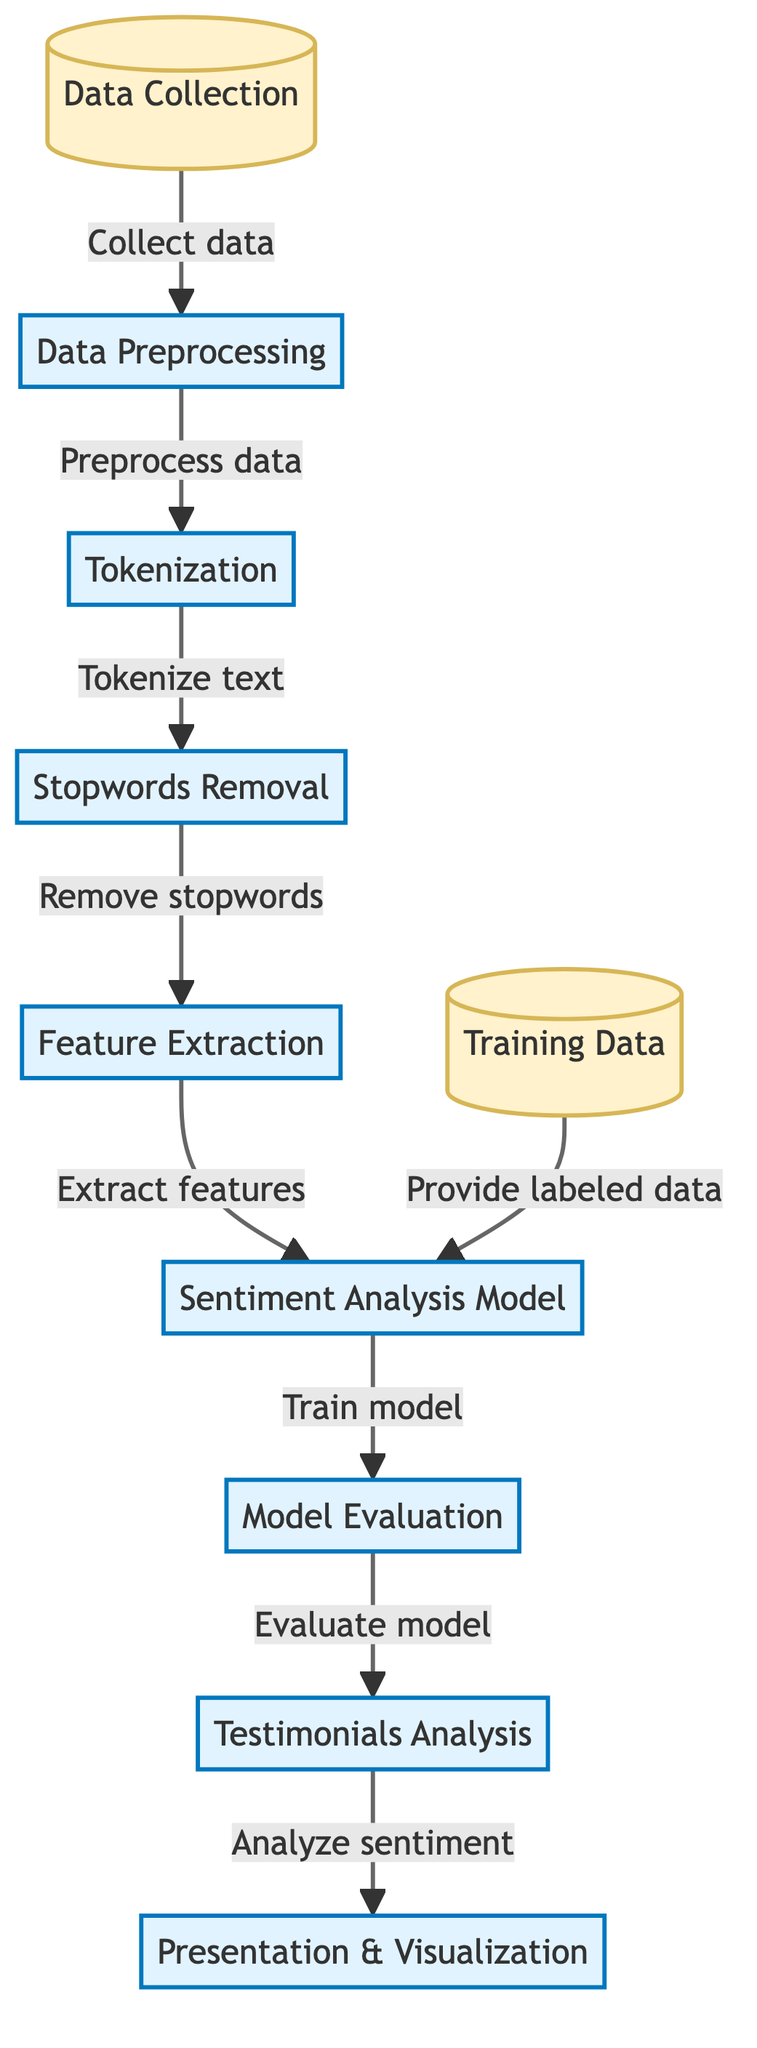What is the first step in the process? The first step in the diagram is "Data Collection," which is depicted as the initial node leading into the process flow.
Answer: Data Collection How many main processes are shown in the diagram? The diagram contains five main processes: Data Preprocessing, Tokenization, Stopwords Removal, Feature Extraction, and Sentiment Analysis Model, totaling five processes.
Answer: Five What is the outcome of the "Model Evaluation" step? The outcome of the "Model Evaluation" process leads directly to the "Testimonials Analysis" step, indicating that the model’s evaluation facilitates the analysis of testimonials.
Answer: Testimonials Analysis What step follows after "Stopwords Removal"? The step that follows "Stopwords Removal" is "Feature Extraction," as represented by the arrow connecting these two processes in the diagram.
Answer: Feature Extraction Which node receives labeled data? The node that receives labeled data is the "Sentiment Analysis Model," as indicated by the arrow labeled "Provide labeled data" pointing towards it.
Answer: Sentiment Analysis Model What type of analysis is performed at the end of the process? At the end of the process, "Testimonials Analysis" is conducted, which signifies that the final analysis step focuses specifically on evaluating the sentiment of testimonials.
Answer: Testimonials Analysis How does the "Sentiment Analysis Model" receive its training data? The "Sentiment Analysis Model" receives its training data from the "Training Data" node, which is illustrated by the arrow connecting both nodes and labeled "Provide labeled data."
Answer: Training Data Which step comes after "Feature Extraction"? "Sentiment Analysis Model" comes after "Feature Extraction," as shown by the flow of arrows moving from one process to the next.
Answer: Sentiment Analysis Model 